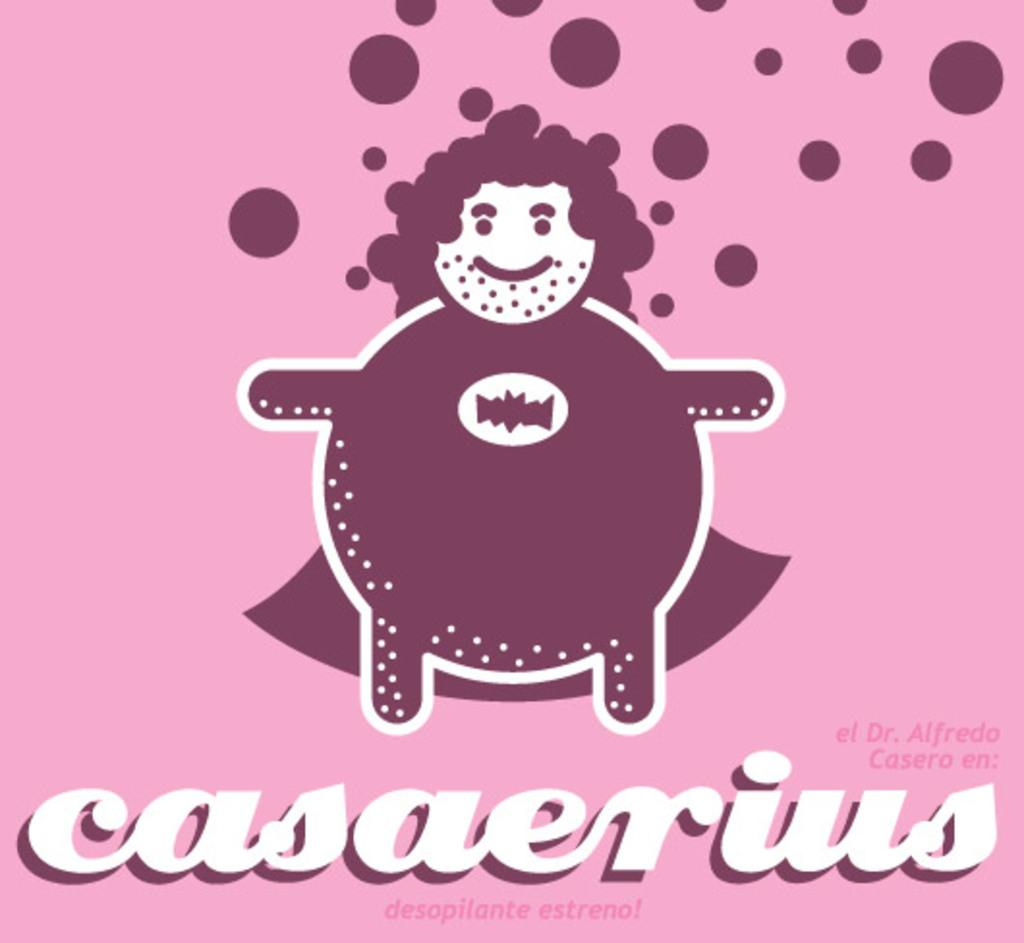Provide a one-sentence caption for the provided image. A fat man dressed like a superhero is casaerius. 